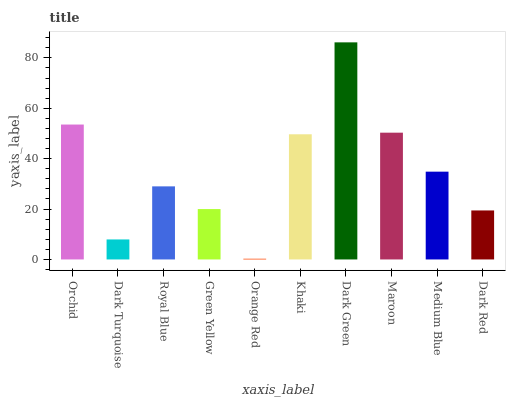Is Orange Red the minimum?
Answer yes or no. Yes. Is Dark Green the maximum?
Answer yes or no. Yes. Is Dark Turquoise the minimum?
Answer yes or no. No. Is Dark Turquoise the maximum?
Answer yes or no. No. Is Orchid greater than Dark Turquoise?
Answer yes or no. Yes. Is Dark Turquoise less than Orchid?
Answer yes or no. Yes. Is Dark Turquoise greater than Orchid?
Answer yes or no. No. Is Orchid less than Dark Turquoise?
Answer yes or no. No. Is Medium Blue the high median?
Answer yes or no. Yes. Is Royal Blue the low median?
Answer yes or no. Yes. Is Orange Red the high median?
Answer yes or no. No. Is Maroon the low median?
Answer yes or no. No. 